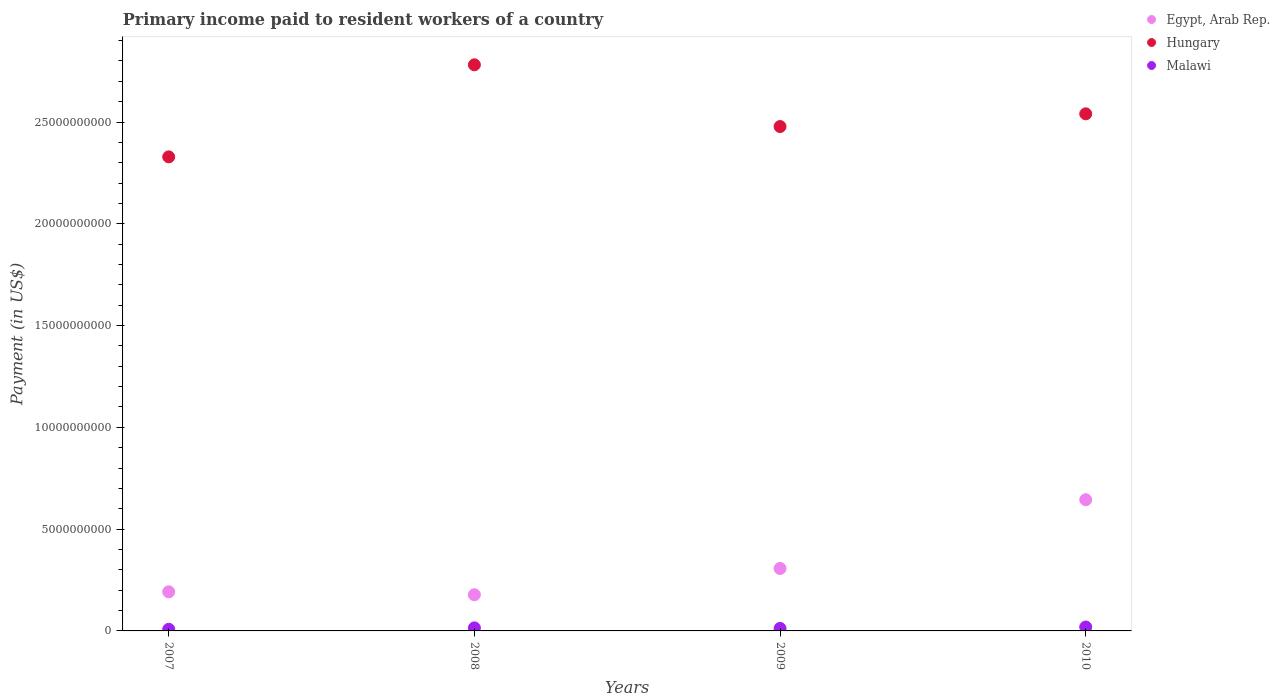How many different coloured dotlines are there?
Provide a short and direct response. 3. What is the amount paid to workers in Egypt, Arab Rep. in 2007?
Offer a very short reply. 1.92e+09. Across all years, what is the maximum amount paid to workers in Egypt, Arab Rep.?
Provide a succinct answer. 6.45e+09. Across all years, what is the minimum amount paid to workers in Malawi?
Make the answer very short. 8.07e+07. What is the total amount paid to workers in Egypt, Arab Rep. in the graph?
Make the answer very short. 1.32e+1. What is the difference between the amount paid to workers in Egypt, Arab Rep. in 2009 and that in 2010?
Offer a terse response. -3.38e+09. What is the difference between the amount paid to workers in Malawi in 2008 and the amount paid to workers in Egypt, Arab Rep. in 2007?
Your response must be concise. -1.77e+09. What is the average amount paid to workers in Egypt, Arab Rep. per year?
Your answer should be very brief. 3.30e+09. In the year 2007, what is the difference between the amount paid to workers in Hungary and amount paid to workers in Malawi?
Offer a terse response. 2.32e+1. What is the ratio of the amount paid to workers in Hungary in 2008 to that in 2009?
Provide a short and direct response. 1.12. Is the amount paid to workers in Malawi in 2007 less than that in 2010?
Give a very brief answer. Yes. Is the difference between the amount paid to workers in Hungary in 2007 and 2009 greater than the difference between the amount paid to workers in Malawi in 2007 and 2009?
Provide a short and direct response. No. What is the difference between the highest and the second highest amount paid to workers in Hungary?
Your answer should be very brief. 2.41e+09. What is the difference between the highest and the lowest amount paid to workers in Malawi?
Make the answer very short. 1.12e+08. Is it the case that in every year, the sum of the amount paid to workers in Malawi and amount paid to workers in Egypt, Arab Rep.  is greater than the amount paid to workers in Hungary?
Ensure brevity in your answer.  No. Is the amount paid to workers in Egypt, Arab Rep. strictly less than the amount paid to workers in Hungary over the years?
Provide a succinct answer. Yes. How many dotlines are there?
Your answer should be very brief. 3. How many years are there in the graph?
Ensure brevity in your answer.  4. Does the graph contain any zero values?
Your answer should be very brief. No. How are the legend labels stacked?
Keep it short and to the point. Vertical. What is the title of the graph?
Ensure brevity in your answer.  Primary income paid to resident workers of a country. Does "Least developed countries" appear as one of the legend labels in the graph?
Offer a terse response. No. What is the label or title of the Y-axis?
Your answer should be very brief. Payment (in US$). What is the Payment (in US$) of Egypt, Arab Rep. in 2007?
Your response must be concise. 1.92e+09. What is the Payment (in US$) in Hungary in 2007?
Offer a terse response. 2.33e+1. What is the Payment (in US$) of Malawi in 2007?
Provide a succinct answer. 8.07e+07. What is the Payment (in US$) in Egypt, Arab Rep. in 2008?
Your answer should be very brief. 1.78e+09. What is the Payment (in US$) of Hungary in 2008?
Offer a terse response. 2.78e+1. What is the Payment (in US$) of Malawi in 2008?
Keep it short and to the point. 1.50e+08. What is the Payment (in US$) in Egypt, Arab Rep. in 2009?
Keep it short and to the point. 3.07e+09. What is the Payment (in US$) in Hungary in 2009?
Provide a short and direct response. 2.48e+1. What is the Payment (in US$) of Malawi in 2009?
Make the answer very short. 1.23e+08. What is the Payment (in US$) of Egypt, Arab Rep. in 2010?
Make the answer very short. 6.45e+09. What is the Payment (in US$) in Hungary in 2010?
Your answer should be very brief. 2.54e+1. What is the Payment (in US$) of Malawi in 2010?
Provide a short and direct response. 1.92e+08. Across all years, what is the maximum Payment (in US$) in Egypt, Arab Rep.?
Provide a succinct answer. 6.45e+09. Across all years, what is the maximum Payment (in US$) of Hungary?
Keep it short and to the point. 2.78e+1. Across all years, what is the maximum Payment (in US$) of Malawi?
Your response must be concise. 1.92e+08. Across all years, what is the minimum Payment (in US$) in Egypt, Arab Rep.?
Make the answer very short. 1.78e+09. Across all years, what is the minimum Payment (in US$) of Hungary?
Your response must be concise. 2.33e+1. Across all years, what is the minimum Payment (in US$) in Malawi?
Your answer should be very brief. 8.07e+07. What is the total Payment (in US$) of Egypt, Arab Rep. in the graph?
Provide a succinct answer. 1.32e+1. What is the total Payment (in US$) in Hungary in the graph?
Keep it short and to the point. 1.01e+11. What is the total Payment (in US$) in Malawi in the graph?
Offer a very short reply. 5.45e+08. What is the difference between the Payment (in US$) of Egypt, Arab Rep. in 2007 and that in 2008?
Offer a very short reply. 1.44e+08. What is the difference between the Payment (in US$) of Hungary in 2007 and that in 2008?
Keep it short and to the point. -4.52e+09. What is the difference between the Payment (in US$) in Malawi in 2007 and that in 2008?
Make the answer very short. -6.90e+07. What is the difference between the Payment (in US$) of Egypt, Arab Rep. in 2007 and that in 2009?
Your answer should be very brief. -1.15e+09. What is the difference between the Payment (in US$) in Hungary in 2007 and that in 2009?
Provide a short and direct response. -1.49e+09. What is the difference between the Payment (in US$) in Malawi in 2007 and that in 2009?
Offer a terse response. -4.18e+07. What is the difference between the Payment (in US$) of Egypt, Arab Rep. in 2007 and that in 2010?
Provide a short and direct response. -4.52e+09. What is the difference between the Payment (in US$) of Hungary in 2007 and that in 2010?
Make the answer very short. -2.11e+09. What is the difference between the Payment (in US$) in Malawi in 2007 and that in 2010?
Provide a succinct answer. -1.12e+08. What is the difference between the Payment (in US$) in Egypt, Arab Rep. in 2008 and that in 2009?
Provide a short and direct response. -1.29e+09. What is the difference between the Payment (in US$) of Hungary in 2008 and that in 2009?
Keep it short and to the point. 3.03e+09. What is the difference between the Payment (in US$) of Malawi in 2008 and that in 2009?
Ensure brevity in your answer.  2.73e+07. What is the difference between the Payment (in US$) in Egypt, Arab Rep. in 2008 and that in 2010?
Give a very brief answer. -4.67e+09. What is the difference between the Payment (in US$) in Hungary in 2008 and that in 2010?
Offer a very short reply. 2.41e+09. What is the difference between the Payment (in US$) of Malawi in 2008 and that in 2010?
Keep it short and to the point. -4.25e+07. What is the difference between the Payment (in US$) in Egypt, Arab Rep. in 2009 and that in 2010?
Provide a succinct answer. -3.38e+09. What is the difference between the Payment (in US$) of Hungary in 2009 and that in 2010?
Give a very brief answer. -6.24e+08. What is the difference between the Payment (in US$) in Malawi in 2009 and that in 2010?
Your answer should be compact. -6.97e+07. What is the difference between the Payment (in US$) of Egypt, Arab Rep. in 2007 and the Payment (in US$) of Hungary in 2008?
Give a very brief answer. -2.59e+1. What is the difference between the Payment (in US$) in Egypt, Arab Rep. in 2007 and the Payment (in US$) in Malawi in 2008?
Provide a succinct answer. 1.77e+09. What is the difference between the Payment (in US$) in Hungary in 2007 and the Payment (in US$) in Malawi in 2008?
Your answer should be compact. 2.31e+1. What is the difference between the Payment (in US$) of Egypt, Arab Rep. in 2007 and the Payment (in US$) of Hungary in 2009?
Provide a succinct answer. -2.29e+1. What is the difference between the Payment (in US$) in Egypt, Arab Rep. in 2007 and the Payment (in US$) in Malawi in 2009?
Keep it short and to the point. 1.80e+09. What is the difference between the Payment (in US$) in Hungary in 2007 and the Payment (in US$) in Malawi in 2009?
Make the answer very short. 2.32e+1. What is the difference between the Payment (in US$) in Egypt, Arab Rep. in 2007 and the Payment (in US$) in Hungary in 2010?
Your answer should be compact. -2.35e+1. What is the difference between the Payment (in US$) of Egypt, Arab Rep. in 2007 and the Payment (in US$) of Malawi in 2010?
Your response must be concise. 1.73e+09. What is the difference between the Payment (in US$) of Hungary in 2007 and the Payment (in US$) of Malawi in 2010?
Your response must be concise. 2.31e+1. What is the difference between the Payment (in US$) of Egypt, Arab Rep. in 2008 and the Payment (in US$) of Hungary in 2009?
Make the answer very short. -2.30e+1. What is the difference between the Payment (in US$) of Egypt, Arab Rep. in 2008 and the Payment (in US$) of Malawi in 2009?
Keep it short and to the point. 1.65e+09. What is the difference between the Payment (in US$) of Hungary in 2008 and the Payment (in US$) of Malawi in 2009?
Provide a succinct answer. 2.77e+1. What is the difference between the Payment (in US$) of Egypt, Arab Rep. in 2008 and the Payment (in US$) of Hungary in 2010?
Your response must be concise. -2.36e+1. What is the difference between the Payment (in US$) of Egypt, Arab Rep. in 2008 and the Payment (in US$) of Malawi in 2010?
Offer a terse response. 1.58e+09. What is the difference between the Payment (in US$) in Hungary in 2008 and the Payment (in US$) in Malawi in 2010?
Offer a very short reply. 2.76e+1. What is the difference between the Payment (in US$) in Egypt, Arab Rep. in 2009 and the Payment (in US$) in Hungary in 2010?
Your answer should be very brief. -2.23e+1. What is the difference between the Payment (in US$) in Egypt, Arab Rep. in 2009 and the Payment (in US$) in Malawi in 2010?
Make the answer very short. 2.88e+09. What is the difference between the Payment (in US$) of Hungary in 2009 and the Payment (in US$) of Malawi in 2010?
Your answer should be compact. 2.46e+1. What is the average Payment (in US$) in Egypt, Arab Rep. per year?
Provide a succinct answer. 3.30e+09. What is the average Payment (in US$) of Hungary per year?
Provide a short and direct response. 2.53e+1. What is the average Payment (in US$) of Malawi per year?
Keep it short and to the point. 1.36e+08. In the year 2007, what is the difference between the Payment (in US$) of Egypt, Arab Rep. and Payment (in US$) of Hungary?
Offer a very short reply. -2.14e+1. In the year 2007, what is the difference between the Payment (in US$) of Egypt, Arab Rep. and Payment (in US$) of Malawi?
Your answer should be compact. 1.84e+09. In the year 2007, what is the difference between the Payment (in US$) in Hungary and Payment (in US$) in Malawi?
Offer a very short reply. 2.32e+1. In the year 2008, what is the difference between the Payment (in US$) of Egypt, Arab Rep. and Payment (in US$) of Hungary?
Give a very brief answer. -2.60e+1. In the year 2008, what is the difference between the Payment (in US$) of Egypt, Arab Rep. and Payment (in US$) of Malawi?
Ensure brevity in your answer.  1.63e+09. In the year 2008, what is the difference between the Payment (in US$) in Hungary and Payment (in US$) in Malawi?
Ensure brevity in your answer.  2.77e+1. In the year 2009, what is the difference between the Payment (in US$) in Egypt, Arab Rep. and Payment (in US$) in Hungary?
Give a very brief answer. -2.17e+1. In the year 2009, what is the difference between the Payment (in US$) in Egypt, Arab Rep. and Payment (in US$) in Malawi?
Provide a succinct answer. 2.95e+09. In the year 2009, what is the difference between the Payment (in US$) of Hungary and Payment (in US$) of Malawi?
Offer a terse response. 2.47e+1. In the year 2010, what is the difference between the Payment (in US$) of Egypt, Arab Rep. and Payment (in US$) of Hungary?
Give a very brief answer. -1.90e+1. In the year 2010, what is the difference between the Payment (in US$) of Egypt, Arab Rep. and Payment (in US$) of Malawi?
Provide a short and direct response. 6.25e+09. In the year 2010, what is the difference between the Payment (in US$) of Hungary and Payment (in US$) of Malawi?
Your answer should be compact. 2.52e+1. What is the ratio of the Payment (in US$) of Egypt, Arab Rep. in 2007 to that in 2008?
Your answer should be compact. 1.08. What is the ratio of the Payment (in US$) in Hungary in 2007 to that in 2008?
Give a very brief answer. 0.84. What is the ratio of the Payment (in US$) of Malawi in 2007 to that in 2008?
Offer a very short reply. 0.54. What is the ratio of the Payment (in US$) of Egypt, Arab Rep. in 2007 to that in 2009?
Make the answer very short. 0.63. What is the ratio of the Payment (in US$) of Hungary in 2007 to that in 2009?
Your response must be concise. 0.94. What is the ratio of the Payment (in US$) of Malawi in 2007 to that in 2009?
Provide a succinct answer. 0.66. What is the ratio of the Payment (in US$) of Egypt, Arab Rep. in 2007 to that in 2010?
Your response must be concise. 0.3. What is the ratio of the Payment (in US$) in Hungary in 2007 to that in 2010?
Keep it short and to the point. 0.92. What is the ratio of the Payment (in US$) in Malawi in 2007 to that in 2010?
Make the answer very short. 0.42. What is the ratio of the Payment (in US$) of Egypt, Arab Rep. in 2008 to that in 2009?
Offer a very short reply. 0.58. What is the ratio of the Payment (in US$) of Hungary in 2008 to that in 2009?
Your answer should be very brief. 1.12. What is the ratio of the Payment (in US$) of Malawi in 2008 to that in 2009?
Your response must be concise. 1.22. What is the ratio of the Payment (in US$) in Egypt, Arab Rep. in 2008 to that in 2010?
Keep it short and to the point. 0.28. What is the ratio of the Payment (in US$) of Hungary in 2008 to that in 2010?
Make the answer very short. 1.09. What is the ratio of the Payment (in US$) in Malawi in 2008 to that in 2010?
Your response must be concise. 0.78. What is the ratio of the Payment (in US$) of Egypt, Arab Rep. in 2009 to that in 2010?
Ensure brevity in your answer.  0.48. What is the ratio of the Payment (in US$) of Hungary in 2009 to that in 2010?
Offer a terse response. 0.98. What is the ratio of the Payment (in US$) of Malawi in 2009 to that in 2010?
Give a very brief answer. 0.64. What is the difference between the highest and the second highest Payment (in US$) in Egypt, Arab Rep.?
Your response must be concise. 3.38e+09. What is the difference between the highest and the second highest Payment (in US$) of Hungary?
Keep it short and to the point. 2.41e+09. What is the difference between the highest and the second highest Payment (in US$) of Malawi?
Provide a succinct answer. 4.25e+07. What is the difference between the highest and the lowest Payment (in US$) in Egypt, Arab Rep.?
Offer a very short reply. 4.67e+09. What is the difference between the highest and the lowest Payment (in US$) of Hungary?
Your answer should be compact. 4.52e+09. What is the difference between the highest and the lowest Payment (in US$) in Malawi?
Provide a succinct answer. 1.12e+08. 